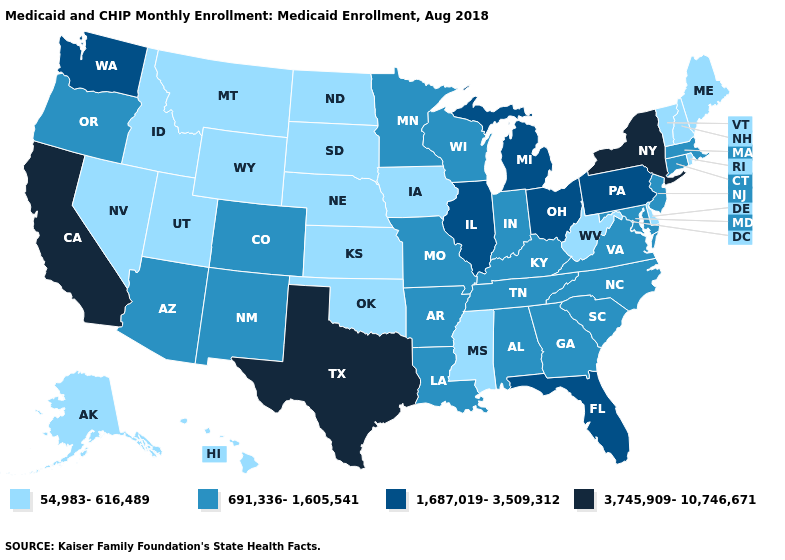Name the states that have a value in the range 54,983-616,489?
Give a very brief answer. Alaska, Delaware, Hawaii, Idaho, Iowa, Kansas, Maine, Mississippi, Montana, Nebraska, Nevada, New Hampshire, North Dakota, Oklahoma, Rhode Island, South Dakota, Utah, Vermont, West Virginia, Wyoming. What is the value of Montana?
Concise answer only. 54,983-616,489. What is the value of Missouri?
Quick response, please. 691,336-1,605,541. Name the states that have a value in the range 54,983-616,489?
Write a very short answer. Alaska, Delaware, Hawaii, Idaho, Iowa, Kansas, Maine, Mississippi, Montana, Nebraska, Nevada, New Hampshire, North Dakota, Oklahoma, Rhode Island, South Dakota, Utah, Vermont, West Virginia, Wyoming. Which states have the lowest value in the USA?
Be succinct. Alaska, Delaware, Hawaii, Idaho, Iowa, Kansas, Maine, Mississippi, Montana, Nebraska, Nevada, New Hampshire, North Dakota, Oklahoma, Rhode Island, South Dakota, Utah, Vermont, West Virginia, Wyoming. Name the states that have a value in the range 1,687,019-3,509,312?
Give a very brief answer. Florida, Illinois, Michigan, Ohio, Pennsylvania, Washington. Name the states that have a value in the range 1,687,019-3,509,312?
Write a very short answer. Florida, Illinois, Michigan, Ohio, Pennsylvania, Washington. Does Oklahoma have the lowest value in the South?
Write a very short answer. Yes. Name the states that have a value in the range 691,336-1,605,541?
Keep it brief. Alabama, Arizona, Arkansas, Colorado, Connecticut, Georgia, Indiana, Kentucky, Louisiana, Maryland, Massachusetts, Minnesota, Missouri, New Jersey, New Mexico, North Carolina, Oregon, South Carolina, Tennessee, Virginia, Wisconsin. Name the states that have a value in the range 3,745,909-10,746,671?
Quick response, please. California, New York, Texas. What is the value of New Jersey?
Quick response, please. 691,336-1,605,541. Which states hav the highest value in the Northeast?
Quick response, please. New York. What is the highest value in the Northeast ?
Be succinct. 3,745,909-10,746,671. Name the states that have a value in the range 3,745,909-10,746,671?
Quick response, please. California, New York, Texas. Name the states that have a value in the range 1,687,019-3,509,312?
Answer briefly. Florida, Illinois, Michigan, Ohio, Pennsylvania, Washington. 